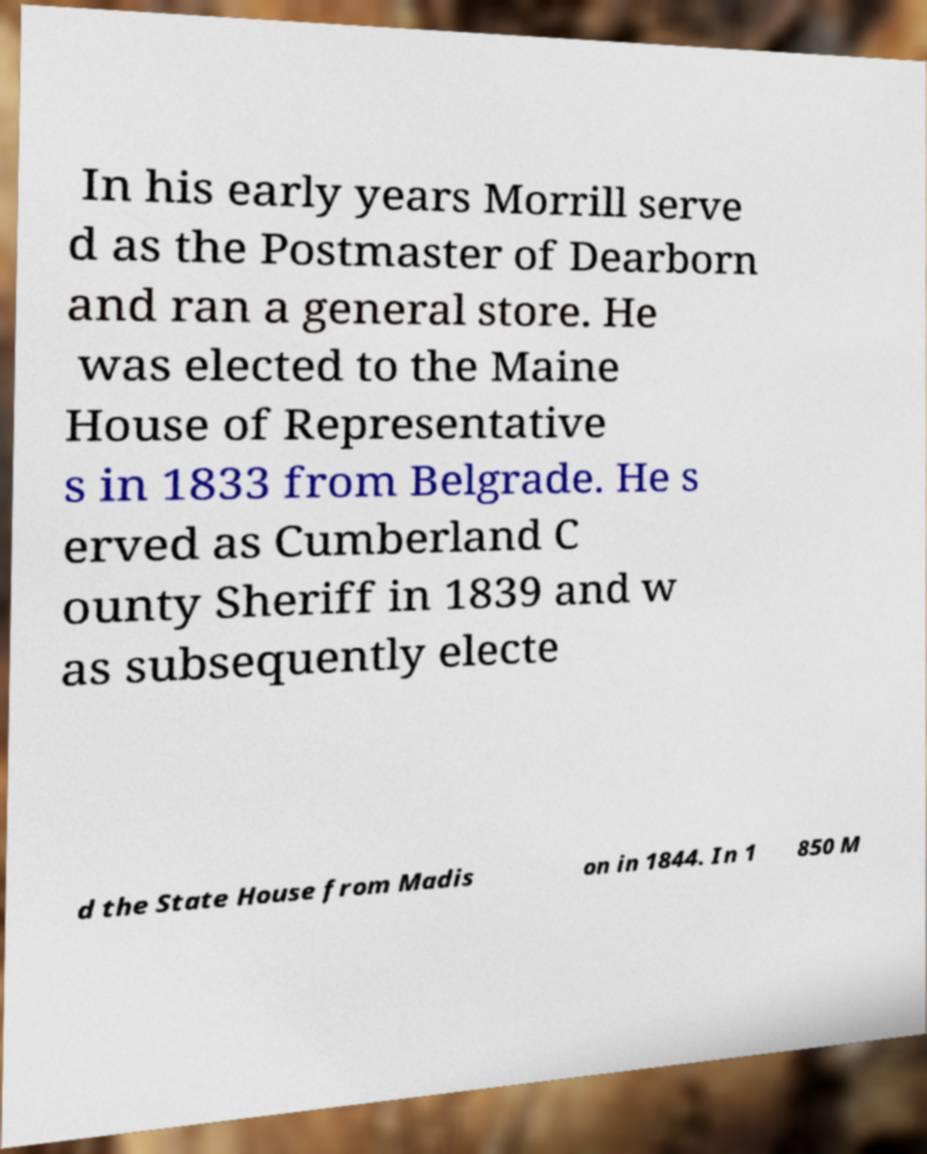What messages or text are displayed in this image? I need them in a readable, typed format. In his early years Morrill serve d as the Postmaster of Dearborn and ran a general store. He was elected to the Maine House of Representative s in 1833 from Belgrade. He s erved as Cumberland C ounty Sheriff in 1839 and w as subsequently electe d the State House from Madis on in 1844. In 1 850 M 